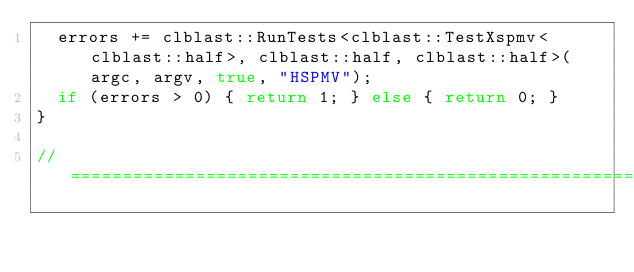Convert code to text. <code><loc_0><loc_0><loc_500><loc_500><_C++_>  errors += clblast::RunTests<clblast::TestXspmv<clblast::half>, clblast::half, clblast::half>(argc, argv, true, "HSPMV");
  if (errors > 0) { return 1; } else { return 0; }
}

// =================================================================================================
</code> 